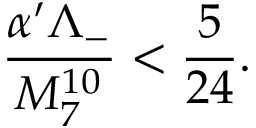<formula> <loc_0><loc_0><loc_500><loc_500>\frac { \alpha ^ { \prime } \Lambda _ { - } } { M _ { 7 } ^ { 1 0 } } < \frac { 5 } { 2 4 } .</formula> 